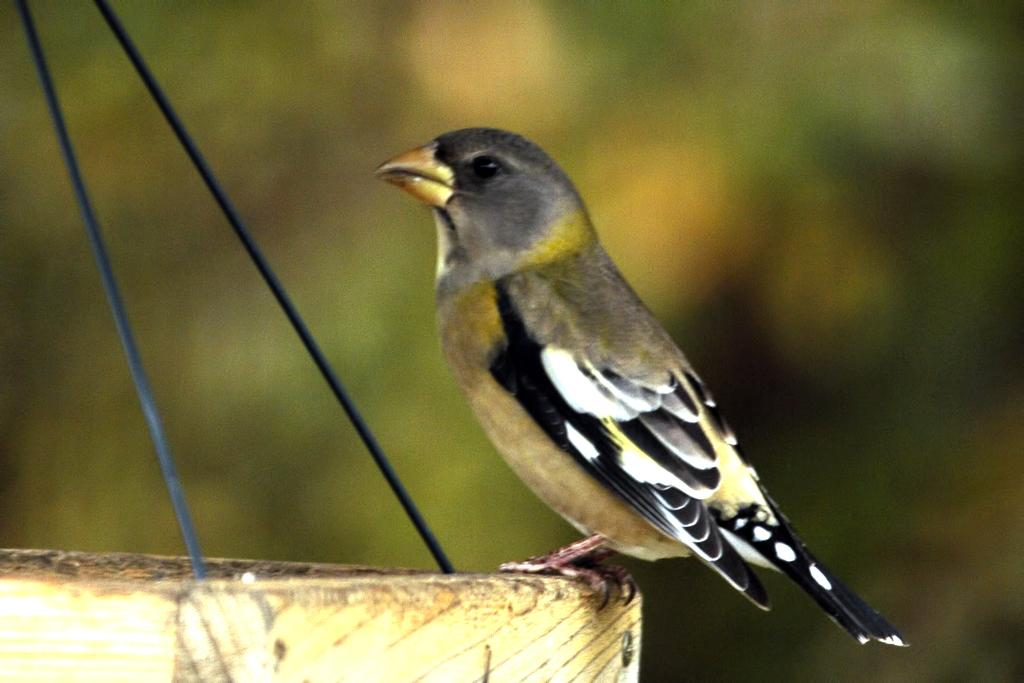What type of animal can be seen in the image? There is a bird in the image. What is the bird standing on? The bird is standing on a wooden object. What type of scale is the bird using to weigh itself in the image? There is no scale present in the image, and the bird is not weighing itself. 